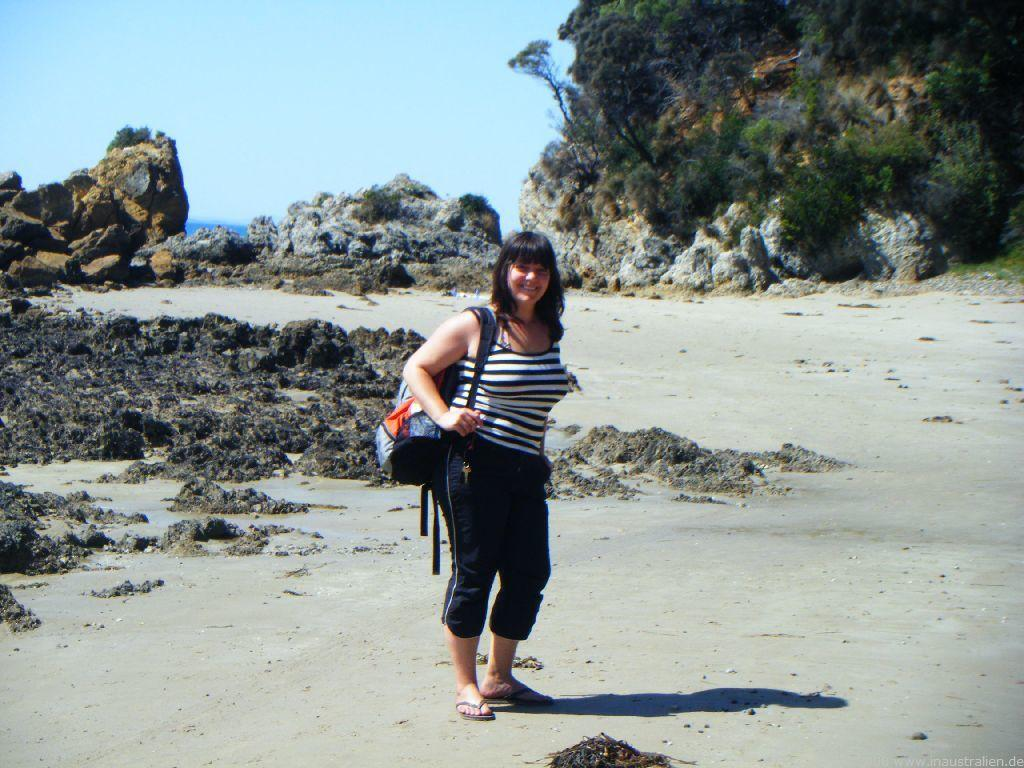Who is present in the image? There is a woman in the image. What is the woman doing in the image? The woman is standing on the ground. What is the woman wearing in the image? The woman is wearing a bag. What can be seen in the background of the image? There is mud, rocks, plants, trees, and the sky visible in the background of the image. What type of zipper can be seen on the woman's bag in the image? There is no zipper visible on the woman's bag in the image. Why is the woman crying in the image? The woman is not crying in the image; there is no indication of any emotional state. 